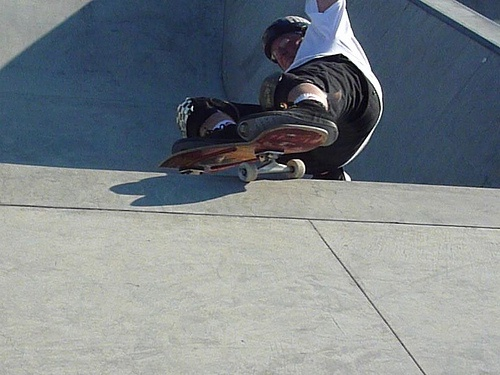Describe the objects in this image and their specific colors. I can see people in darkgray, black, gray, and white tones and skateboard in darkgray, black, gray, and maroon tones in this image. 